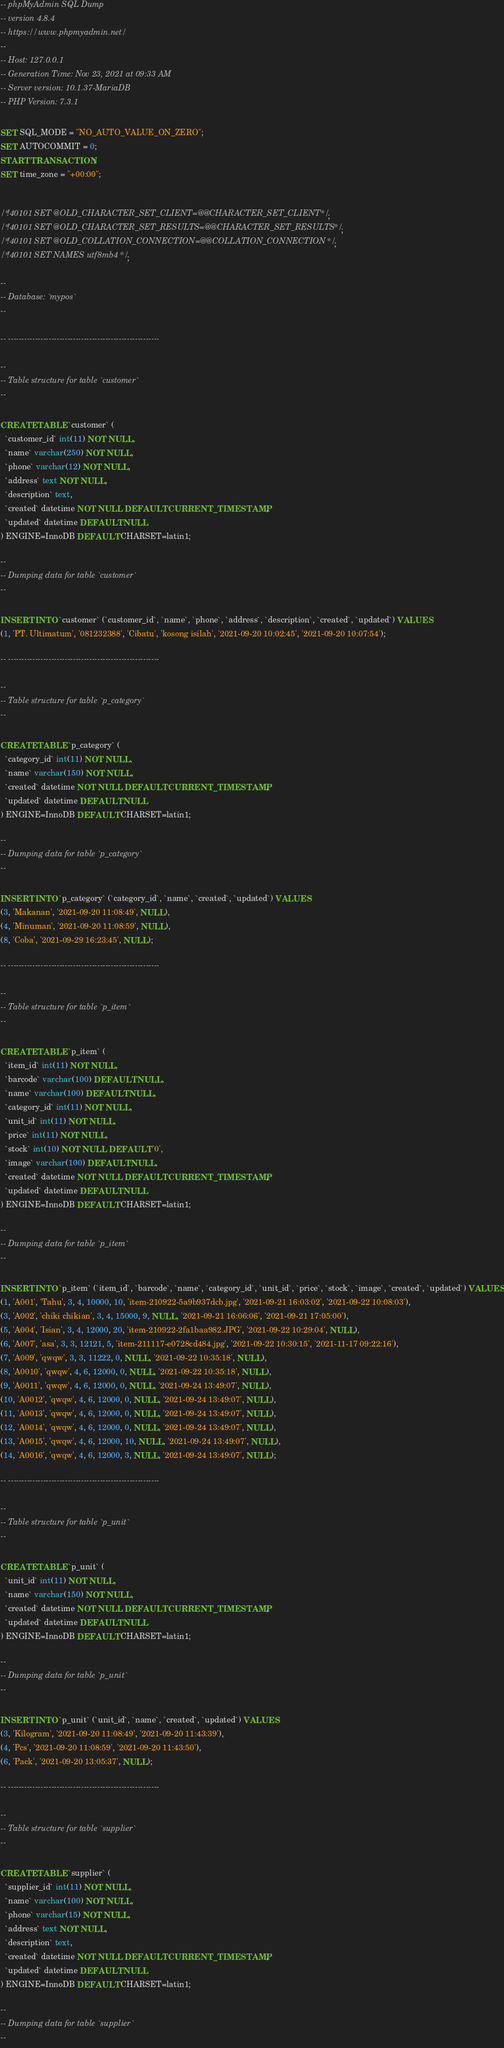<code> <loc_0><loc_0><loc_500><loc_500><_SQL_>-- phpMyAdmin SQL Dump
-- version 4.8.4
-- https://www.phpmyadmin.net/
--
-- Host: 127.0.0.1
-- Generation Time: Nov 23, 2021 at 09:33 AM
-- Server version: 10.1.37-MariaDB
-- PHP Version: 7.3.1

SET SQL_MODE = "NO_AUTO_VALUE_ON_ZERO";
SET AUTOCOMMIT = 0;
START TRANSACTION;
SET time_zone = "+00:00";


/*!40101 SET @OLD_CHARACTER_SET_CLIENT=@@CHARACTER_SET_CLIENT */;
/*!40101 SET @OLD_CHARACTER_SET_RESULTS=@@CHARACTER_SET_RESULTS */;
/*!40101 SET @OLD_COLLATION_CONNECTION=@@COLLATION_CONNECTION */;
/*!40101 SET NAMES utf8mb4 */;

--
-- Database: `mypos`
--

-- --------------------------------------------------------

--
-- Table structure for table `customer`
--

CREATE TABLE `customer` (
  `customer_id` int(11) NOT NULL,
  `name` varchar(250) NOT NULL,
  `phone` varchar(12) NOT NULL,
  `address` text NOT NULL,
  `description` text,
  `created` datetime NOT NULL DEFAULT CURRENT_TIMESTAMP,
  `updated` datetime DEFAULT NULL
) ENGINE=InnoDB DEFAULT CHARSET=latin1;

--
-- Dumping data for table `customer`
--

INSERT INTO `customer` (`customer_id`, `name`, `phone`, `address`, `description`, `created`, `updated`) VALUES
(1, 'PT. Ultimatum', '081232388', 'Cibatu', 'kosong isilah', '2021-09-20 10:02:45', '2021-09-20 10:07:54');

-- --------------------------------------------------------

--
-- Table structure for table `p_category`
--

CREATE TABLE `p_category` (
  `category_id` int(11) NOT NULL,
  `name` varchar(150) NOT NULL,
  `created` datetime NOT NULL DEFAULT CURRENT_TIMESTAMP,
  `updated` datetime DEFAULT NULL
) ENGINE=InnoDB DEFAULT CHARSET=latin1;

--
-- Dumping data for table `p_category`
--

INSERT INTO `p_category` (`category_id`, `name`, `created`, `updated`) VALUES
(3, 'Makanan', '2021-09-20 11:08:49', NULL),
(4, 'Minuman', '2021-09-20 11:08:59', NULL),
(8, 'Coba', '2021-09-29 16:23:45', NULL);

-- --------------------------------------------------------

--
-- Table structure for table `p_item`
--

CREATE TABLE `p_item` (
  `item_id` int(11) NOT NULL,
  `barcode` varchar(100) DEFAULT NULL,
  `name` varchar(100) DEFAULT NULL,
  `category_id` int(11) NOT NULL,
  `unit_id` int(11) NOT NULL,
  `price` int(11) NOT NULL,
  `stock` int(10) NOT NULL DEFAULT '0',
  `image` varchar(100) DEFAULT NULL,
  `created` datetime NOT NULL DEFAULT CURRENT_TIMESTAMP,
  `updated` datetime DEFAULT NULL
) ENGINE=InnoDB DEFAULT CHARSET=latin1;

--
-- Dumping data for table `p_item`
--

INSERT INTO `p_item` (`item_id`, `barcode`, `name`, `category_id`, `unit_id`, `price`, `stock`, `image`, `created`, `updated`) VALUES
(1, 'A001', 'Tahu', 3, 4, 10000, 10, 'item-210922-5a9b937dcb.jpg', '2021-09-21 16:03:02', '2021-09-22 10:08:03'),
(3, 'A002', 'chiki chikian', 3, 4, 15000, 9, NULL, '2021-09-21 16:06:06', '2021-09-21 17:05:00'),
(5, 'A004', 'Isian', 3, 4, 12000, 20, 'item-210922-2fa1baa982.JPG', '2021-09-22 10:29:04', NULL),
(6, 'A007', 'asa', 3, 3, 12121, 5, 'item-211117-e0728cd484.jpg', '2021-09-22 10:30:15', '2021-11-17 09:22:16'),
(7, 'A009', 'qwqw', 3, 3, 11222, 0, NULL, '2021-09-22 10:35:18', NULL),
(8, 'A0010', 'qwqw', 4, 6, 12000, 0, NULL, '2021-09-22 10:35:18', NULL),
(9, 'A0011', 'qwqw', 4, 6, 12000, 0, NULL, '2021-09-24 13:49:07', NULL),
(10, 'A0012', 'qwqw', 4, 6, 12000, 0, NULL, '2021-09-24 13:49:07', NULL),
(11, 'A0013', 'qwqw', 4, 6, 12000, 0, NULL, '2021-09-24 13:49:07', NULL),
(12, 'A0014', 'qwqw', 4, 6, 12000, 0, NULL, '2021-09-24 13:49:07', NULL),
(13, 'A0015', 'qwqw', 4, 6, 12000, 10, NULL, '2021-09-24 13:49:07', NULL),
(14, 'A0016', 'qwqw', 4, 6, 12000, 3, NULL, '2021-09-24 13:49:07', NULL);

-- --------------------------------------------------------

--
-- Table structure for table `p_unit`
--

CREATE TABLE `p_unit` (
  `unit_id` int(11) NOT NULL,
  `name` varchar(150) NOT NULL,
  `created` datetime NOT NULL DEFAULT CURRENT_TIMESTAMP,
  `updated` datetime DEFAULT NULL
) ENGINE=InnoDB DEFAULT CHARSET=latin1;

--
-- Dumping data for table `p_unit`
--

INSERT INTO `p_unit` (`unit_id`, `name`, `created`, `updated`) VALUES
(3, 'Kilogram', '2021-09-20 11:08:49', '2021-09-20 11:43:39'),
(4, 'Pcs', '2021-09-20 11:08:59', '2021-09-20 11:43:50'),
(6, 'Pack', '2021-09-20 13:05:37', NULL);

-- --------------------------------------------------------

--
-- Table structure for table `supplier`
--

CREATE TABLE `supplier` (
  `supplier_id` int(11) NOT NULL,
  `name` varchar(100) NOT NULL,
  `phone` varchar(15) NOT NULL,
  `address` text NOT NULL,
  `description` text,
  `created` datetime NOT NULL DEFAULT CURRENT_TIMESTAMP,
  `updated` datetime DEFAULT NULL
) ENGINE=InnoDB DEFAULT CHARSET=latin1;

--
-- Dumping data for table `supplier`
--
</code> 